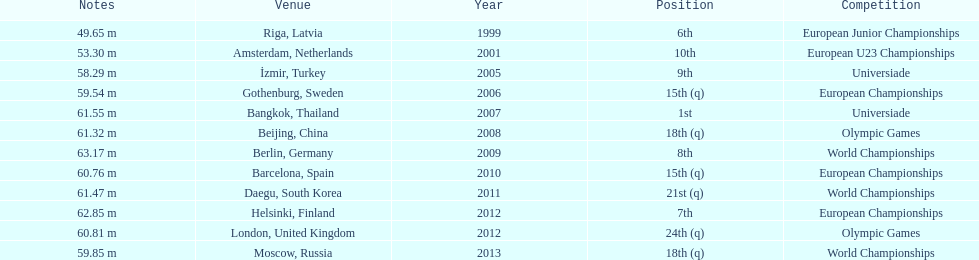Which year held the most competitions? 2012. 